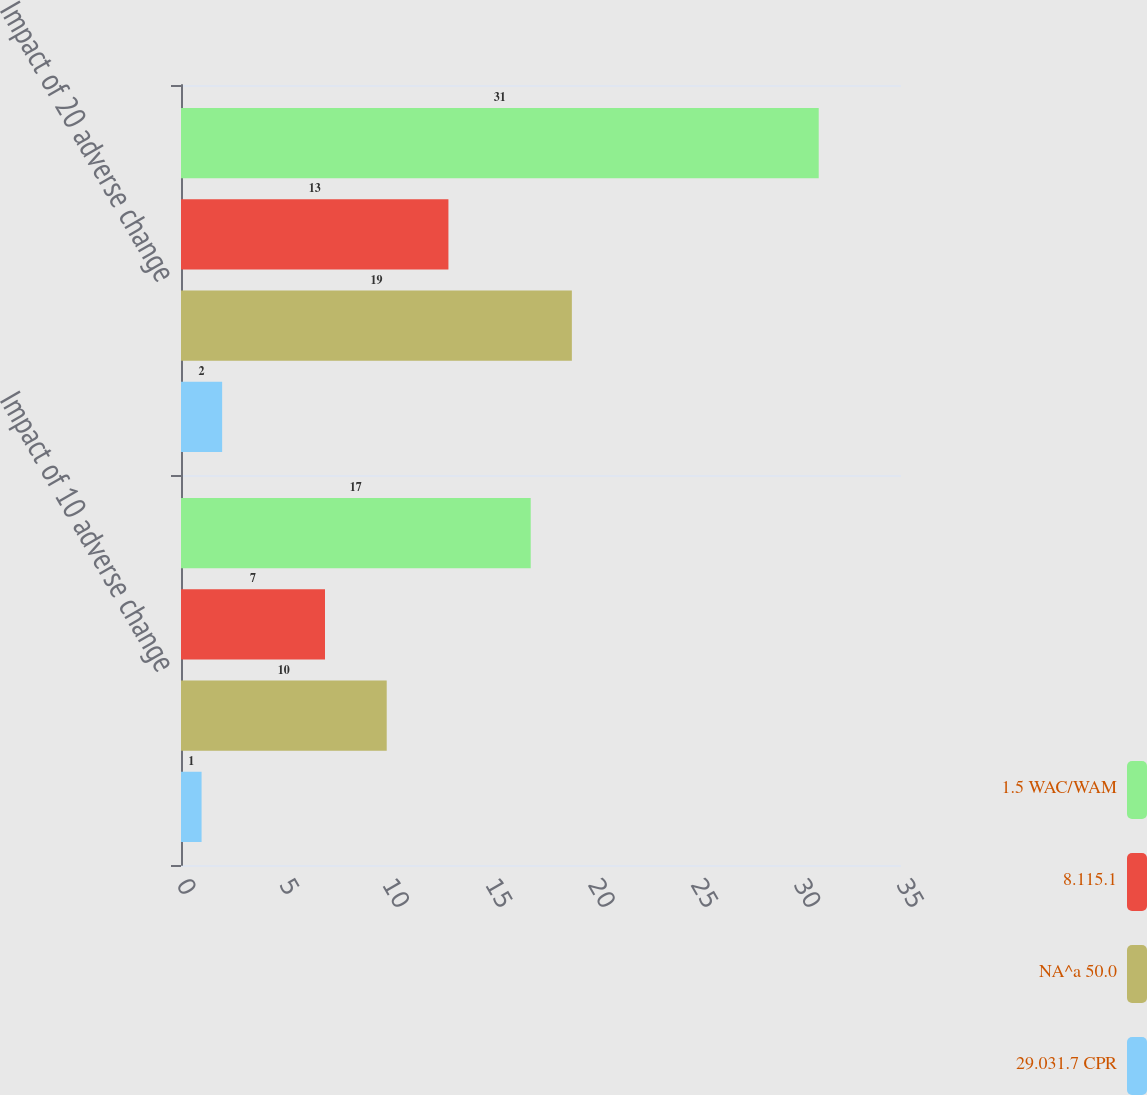Convert chart. <chart><loc_0><loc_0><loc_500><loc_500><stacked_bar_chart><ecel><fcel>Impact of 10 adverse change<fcel>Impact of 20 adverse change<nl><fcel>1.5 WAC/WAM<fcel>17<fcel>31<nl><fcel>8.115.1<fcel>7<fcel>13<nl><fcel>NA^a 50.0<fcel>10<fcel>19<nl><fcel>29.031.7 CPR<fcel>1<fcel>2<nl></chart> 